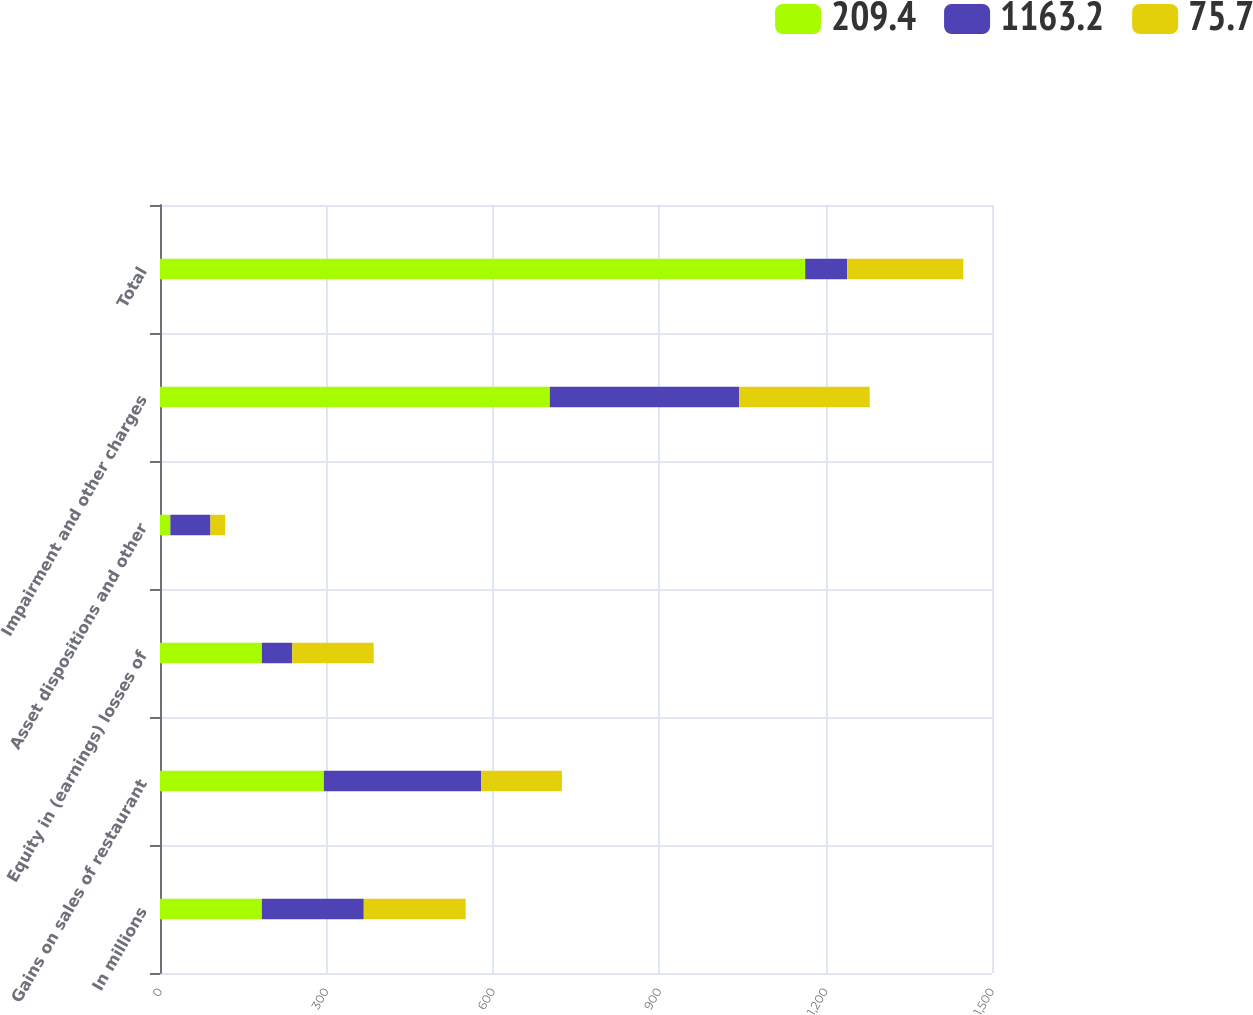<chart> <loc_0><loc_0><loc_500><loc_500><stacked_bar_chart><ecel><fcel>In millions<fcel>Gains on sales of restaurant<fcel>Equity in (earnings) losses of<fcel>Asset dispositions and other<fcel>Impairment and other charges<fcel>Total<nl><fcel>209.4<fcel>183.7<fcel>295.4<fcel>183.7<fcel>18.7<fcel>702.8<fcel>1163.2<nl><fcel>1163.2<fcel>183.7<fcel>283.4<fcel>54.8<fcel>72.3<fcel>341.6<fcel>75.7<nl><fcel>75.7<fcel>183.7<fcel>145.9<fcel>146.8<fcel>26.6<fcel>235.1<fcel>209.4<nl></chart> 